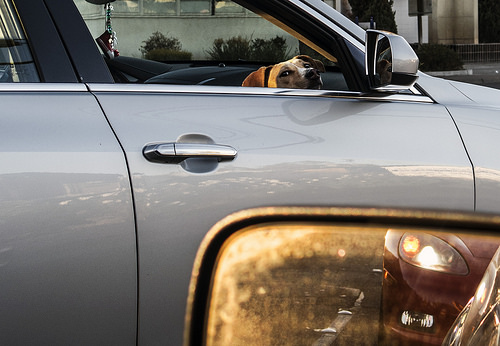<image>
Is there a dog in the shoes? No. The dog is not contained within the shoes. These objects have a different spatial relationship. 